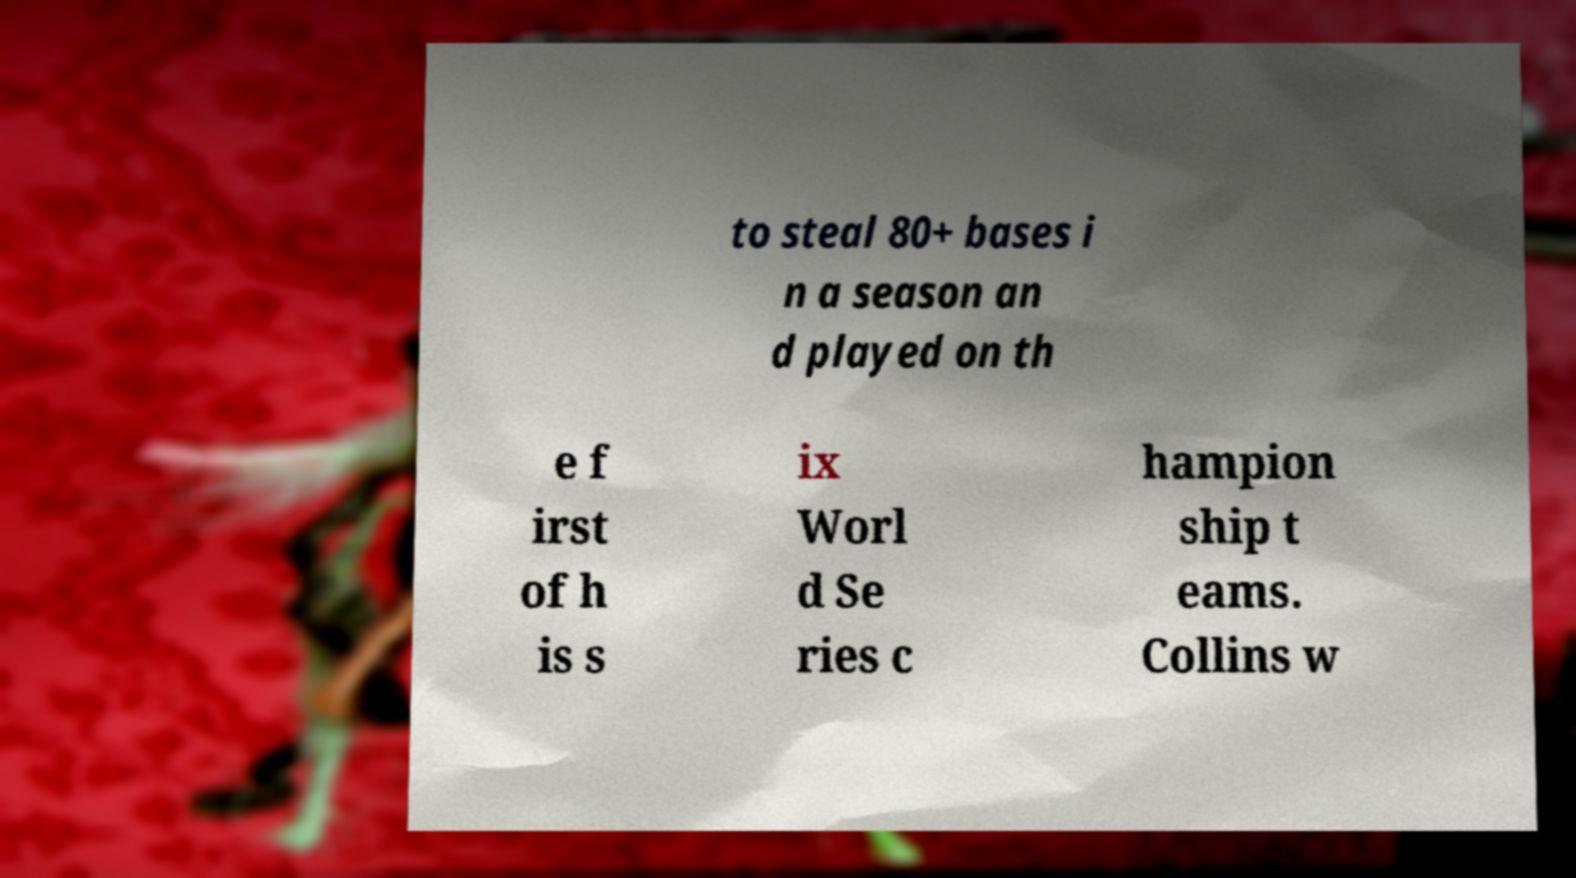What messages or text are displayed in this image? I need them in a readable, typed format. to steal 80+ bases i n a season an d played on th e f irst of h is s ix Worl d Se ries c hampion ship t eams. Collins w 